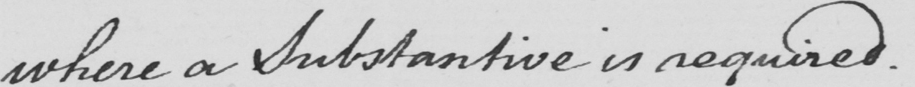What is written in this line of handwriting? where a Substantive is required . 